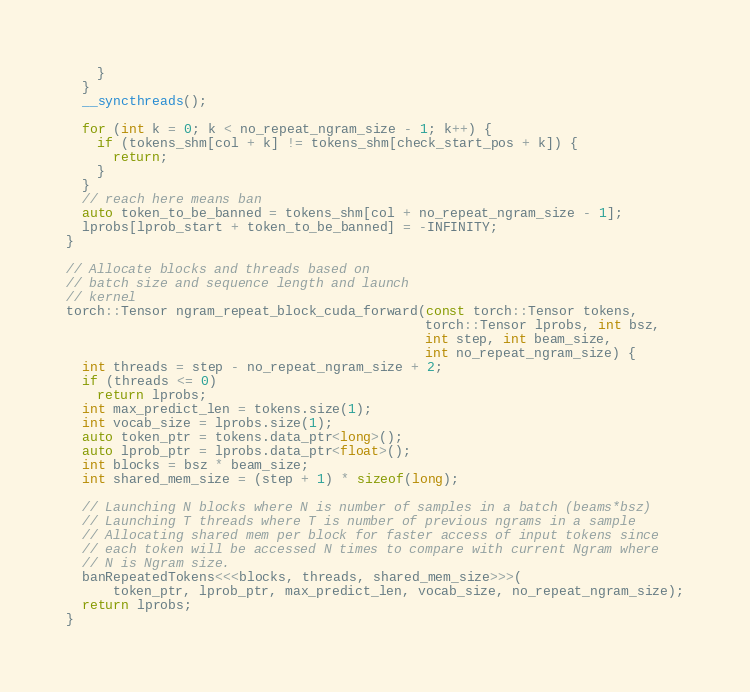<code> <loc_0><loc_0><loc_500><loc_500><_Cuda_>    }
  }
  __syncthreads();

  for (int k = 0; k < no_repeat_ngram_size - 1; k++) {
    if (tokens_shm[col + k] != tokens_shm[check_start_pos + k]) {
      return;
    }
  }
  // reach here means ban
  auto token_to_be_banned = tokens_shm[col + no_repeat_ngram_size - 1];
  lprobs[lprob_start + token_to_be_banned] = -INFINITY;
}

// Allocate blocks and threads based on
// batch size and sequence length and launch
// kernel
torch::Tensor ngram_repeat_block_cuda_forward(const torch::Tensor tokens,
                                              torch::Tensor lprobs, int bsz,
                                              int step, int beam_size,
                                              int no_repeat_ngram_size) {
  int threads = step - no_repeat_ngram_size + 2;
  if (threads <= 0)
    return lprobs;
  int max_predict_len = tokens.size(1);
  int vocab_size = lprobs.size(1);
  auto token_ptr = tokens.data_ptr<long>();
  auto lprob_ptr = lprobs.data_ptr<float>();
  int blocks = bsz * beam_size;
  int shared_mem_size = (step + 1) * sizeof(long);

  // Launching N blocks where N is number of samples in a batch (beams*bsz)
  // Launching T threads where T is number of previous ngrams in a sample
  // Allocating shared mem per block for faster access of input tokens since
  // each token will be accessed N times to compare with current Ngram where
  // N is Ngram size.
  banRepeatedTokens<<<blocks, threads, shared_mem_size>>>(
      token_ptr, lprob_ptr, max_predict_len, vocab_size, no_repeat_ngram_size);
  return lprobs;
}
</code> 